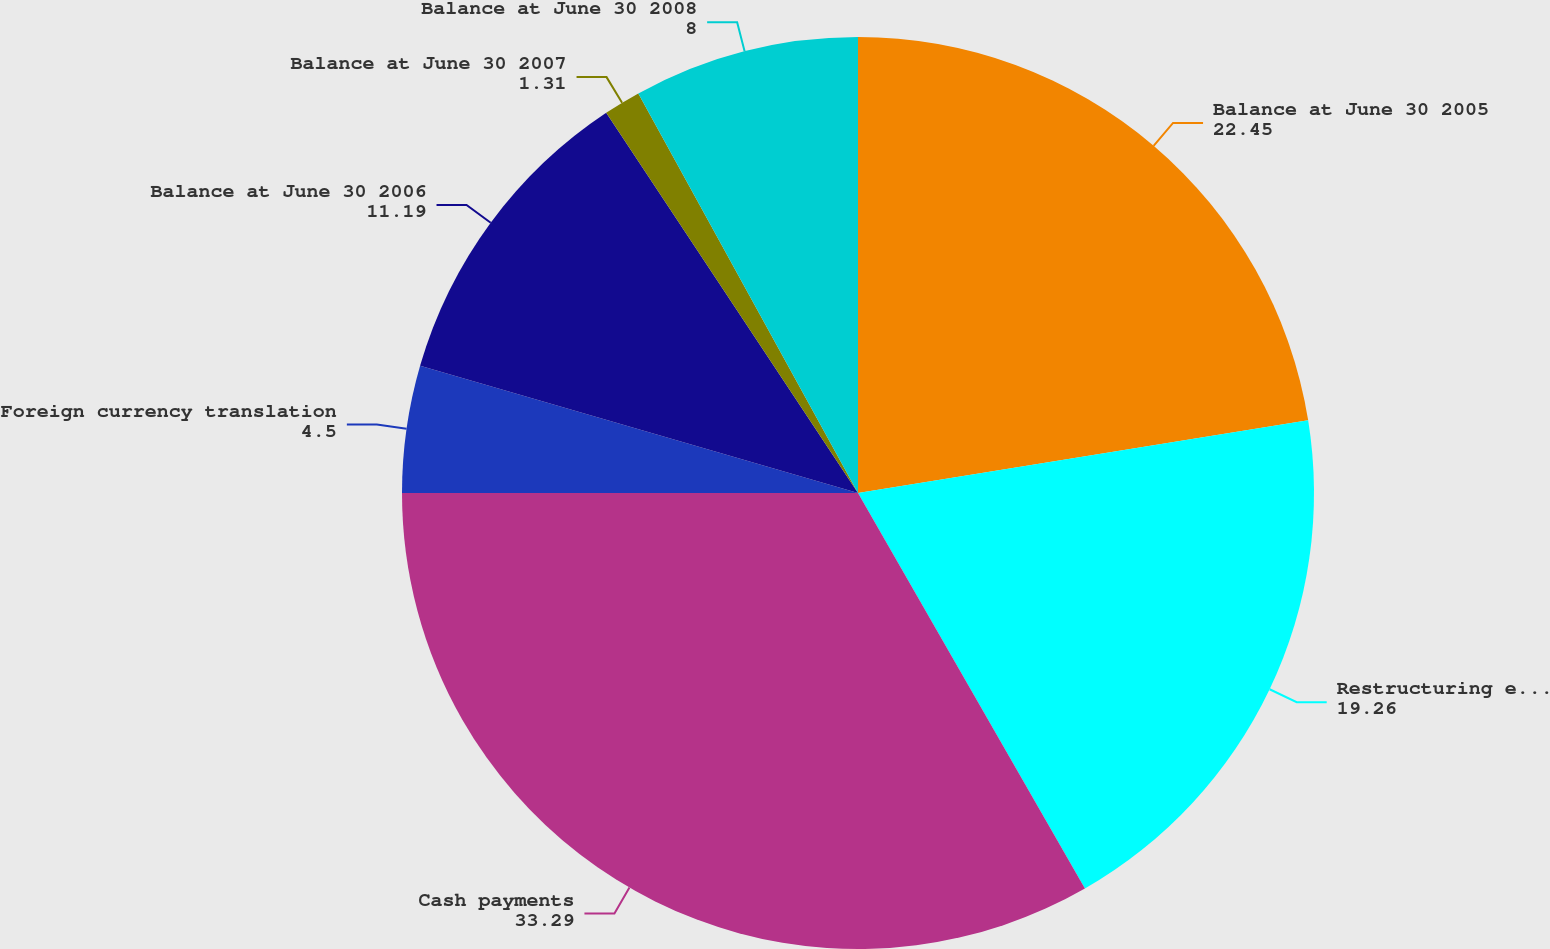Convert chart. <chart><loc_0><loc_0><loc_500><loc_500><pie_chart><fcel>Balance at June 30 2005<fcel>Restructuring expenses<fcel>Cash payments<fcel>Foreign currency translation<fcel>Balance at June 30 2006<fcel>Balance at June 30 2007<fcel>Balance at June 30 2008<nl><fcel>22.45%<fcel>19.26%<fcel>33.29%<fcel>4.5%<fcel>11.19%<fcel>1.31%<fcel>8.0%<nl></chart> 